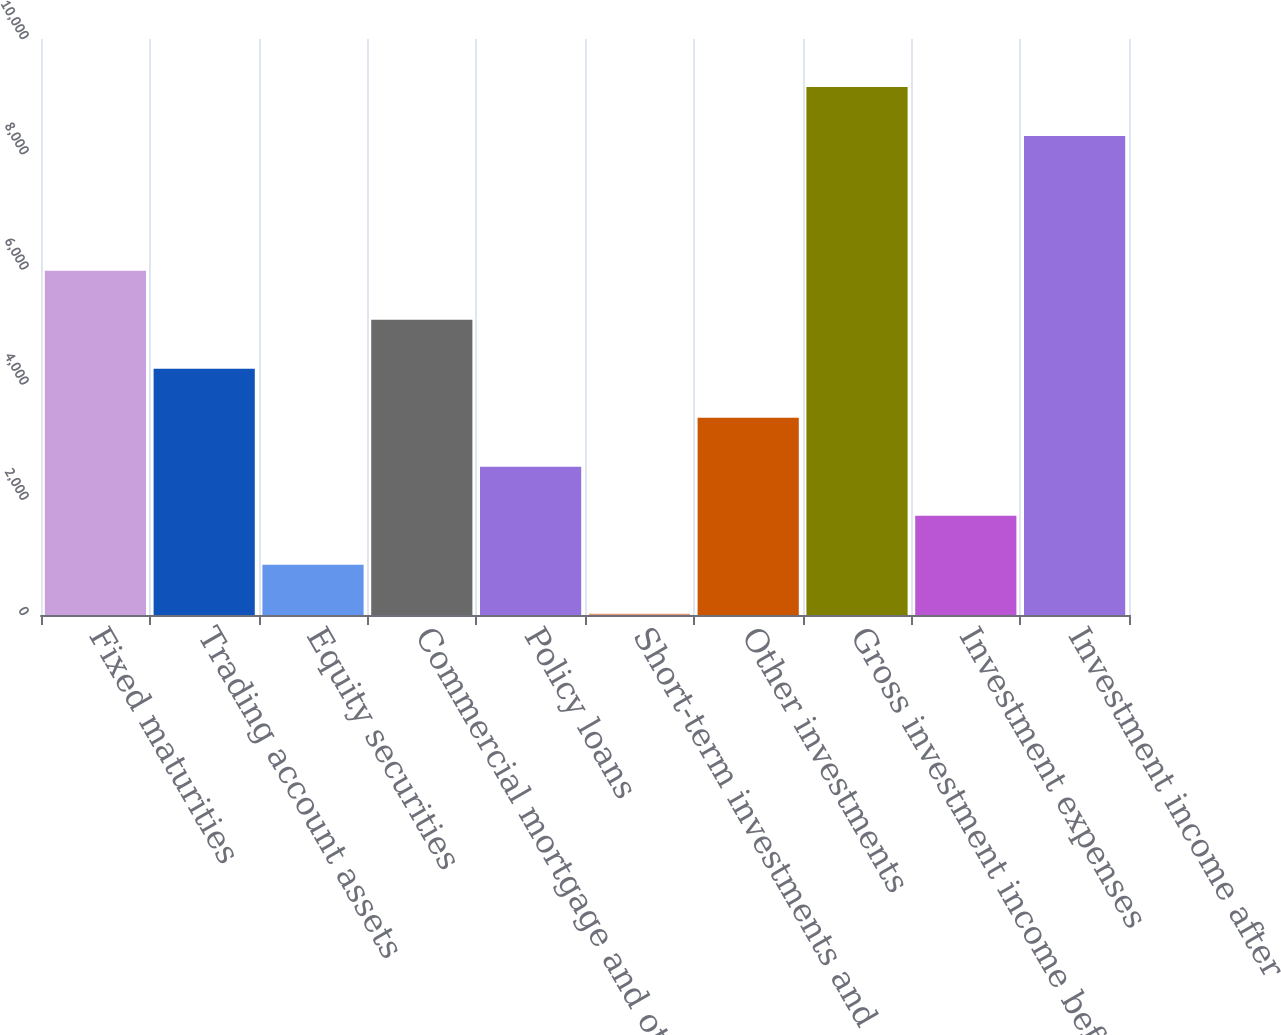Convert chart to OTSL. <chart><loc_0><loc_0><loc_500><loc_500><bar_chart><fcel>Fixed maturities<fcel>Trading account assets<fcel>Equity securities<fcel>Commercial mortgage and other<fcel>Policy loans<fcel>Short-term investments and<fcel>Other investments<fcel>Gross investment income before<fcel>Investment expenses<fcel>Investment income after<nl><fcel>5974.8<fcel>4274<fcel>872.4<fcel>5124.4<fcel>2573.2<fcel>22<fcel>3423.6<fcel>9167.4<fcel>1722.8<fcel>8317<nl></chart> 